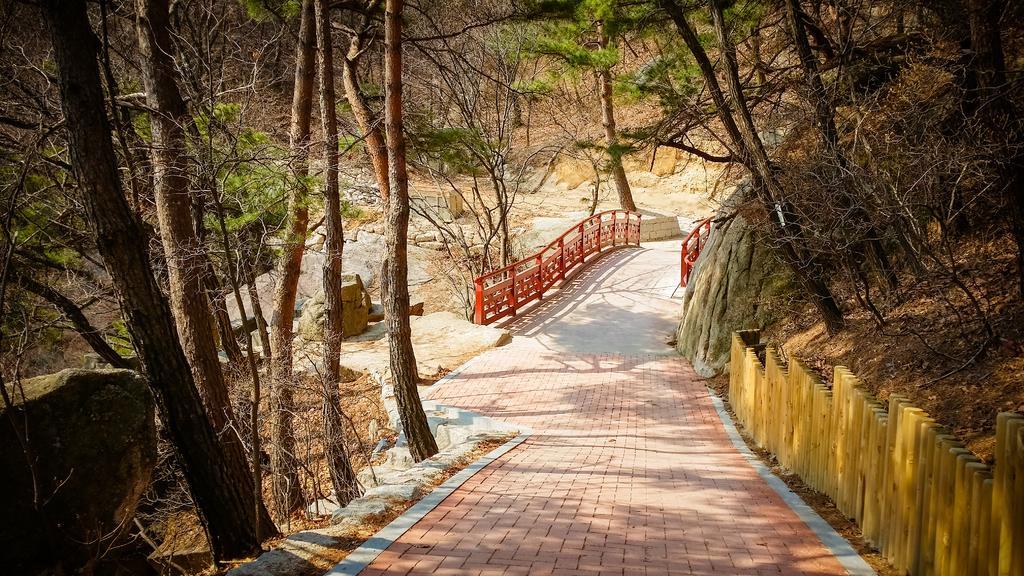How would you summarize this image in a sentence or two? This picture is clicked outside. In the foreground we can see the pavement and the railings and we can see the trees and rocks. In the background we can see the trees and some other objects. 